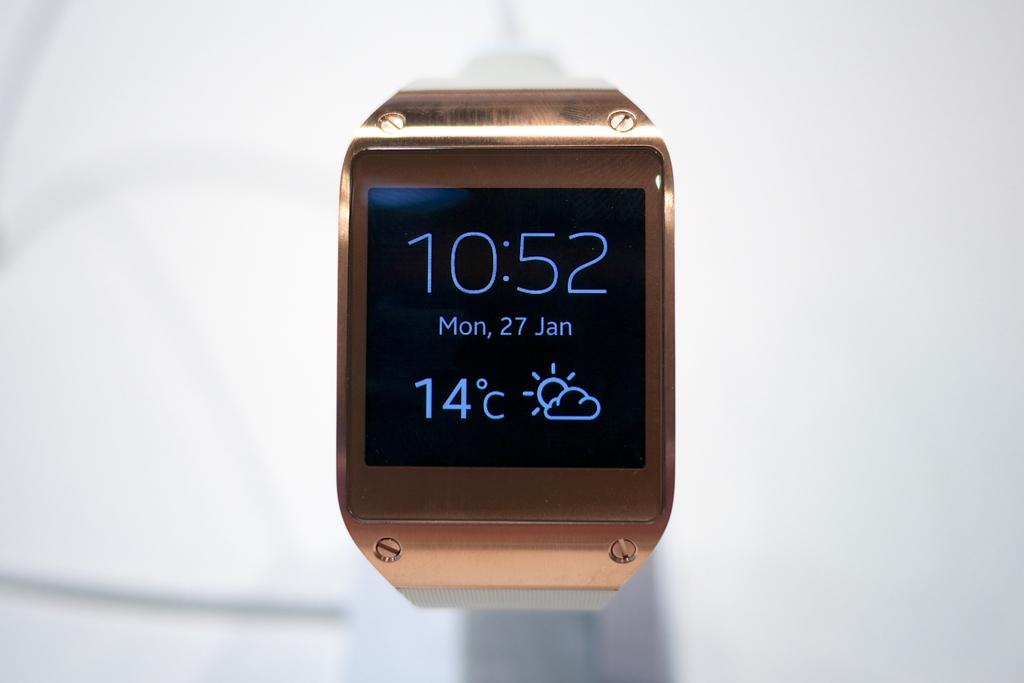Provide a one-sentence caption for the provided image. A square faced watch with the time 10:52 showing on the face as well as the temperature and date. 